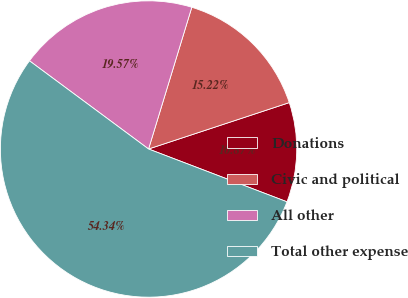Convert chart. <chart><loc_0><loc_0><loc_500><loc_500><pie_chart><fcel>Donations<fcel>Civic and political<fcel>All other<fcel>Total other expense<nl><fcel>10.87%<fcel>15.22%<fcel>19.57%<fcel>54.35%<nl></chart> 